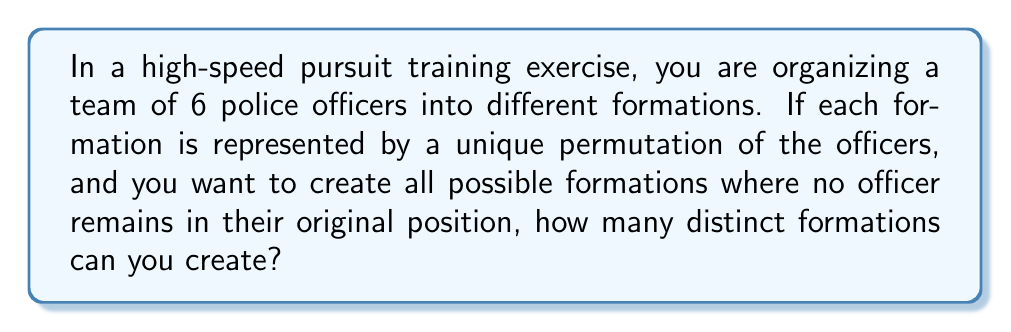Can you answer this question? To solve this problem, we need to use the concept of derangements in permutation groups.

1) First, let's recall what a derangement is:
   A derangement is a permutation where no element appears in its original position.

2) The number of derangements for n elements is given by the formula:
   
   $$D_n = n! \sum_{k=0}^n \frac{(-1)^k}{k!}$$

3) In this case, we have 6 officers, so n = 6.

4) Let's calculate $D_6$:

   $$D_6 = 6! \sum_{k=0}^6 \frac{(-1)^k}{k!}$$

5) Expanding the sum:

   $$D_6 = 6! \left(\frac{1}{0!} - \frac{1}{1!} + \frac{1}{2!} - \frac{1}{3!} + \frac{1}{4!} - \frac{1}{5!} + \frac{1}{6!}\right)$$

6) Calculating:

   $$D_6 = 720 \left(1 - 1 + \frac{1}{2} - \frac{1}{6} + \frac{1}{24} - \frac{1}{120} + \frac{1}{720}\right)$$

7) Simplifying:

   $$D_6 = 720 \cdot \frac{265}{720} = 265$$

Therefore, there are 265 possible formations where no officer remains in their original position.
Answer: 265 distinct formations 